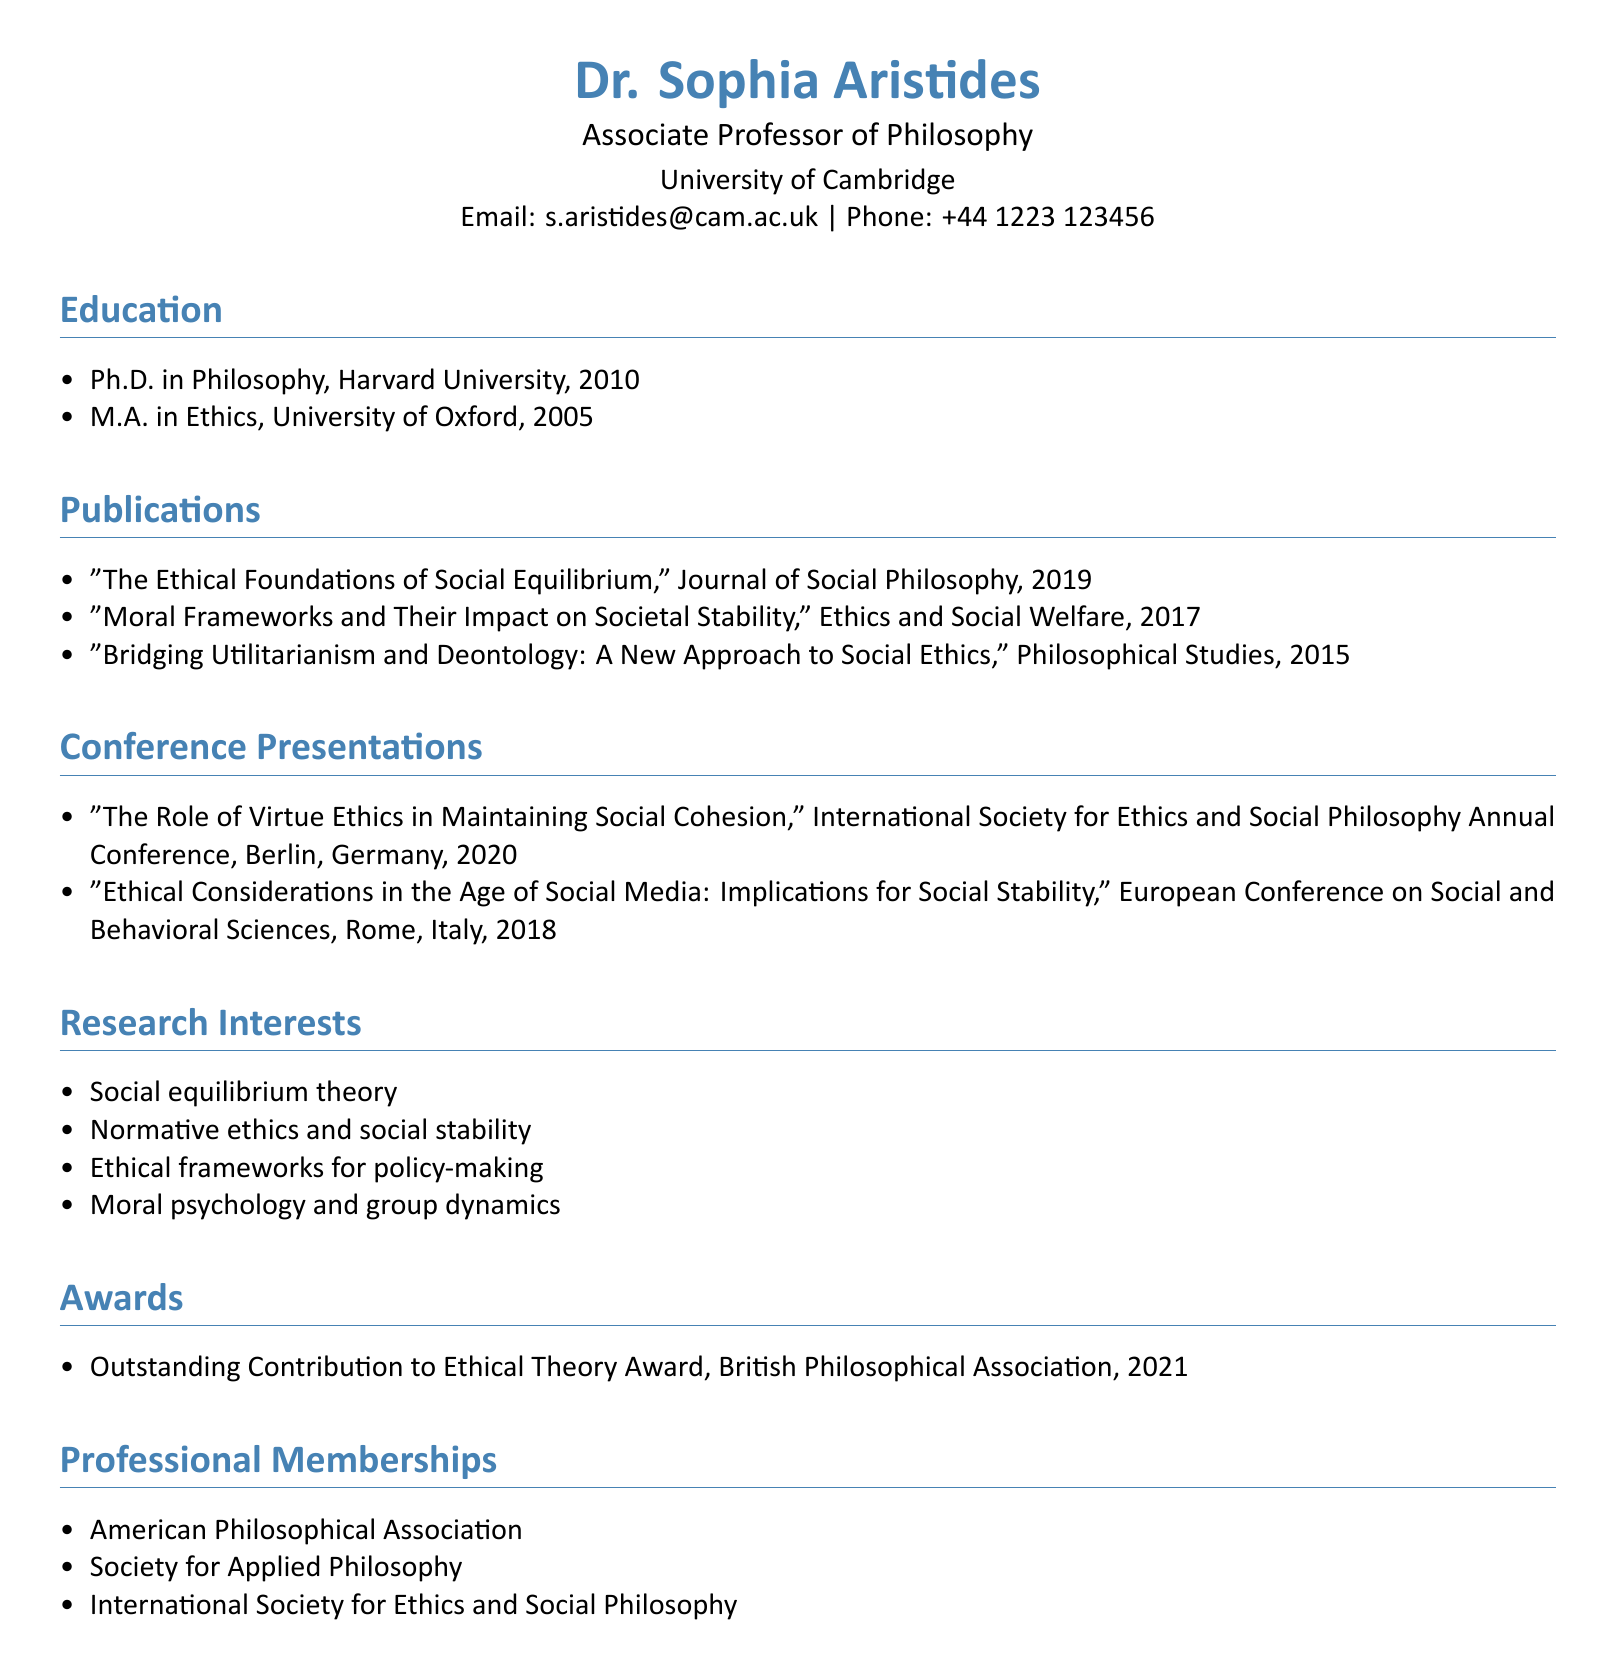What is Dr. Sophia Aristides's title? The title is a specific piece of information provided in the personal information section of the document.
Answer: Associate Professor of Philosophy In which year did Dr. Sophia Aristides complete her Ph.D.? This information is located under the education section where details about the Ph.D. are provided.
Answer: 2010 How many publications does Dr. Sophia Aristides have listed? The total number of publications is found by counting the items listed under the publications section.
Answer: 3 What was the title of the conference presentation in Berlin? This title can be found under the conference presentations section, specifically mentioning the Berlin conference.
Answer: The Role of Virtue Ethics in Maintaining Social Cohesion Which award did Dr. Sophia Aristides receive in 2021? The specific award is detailed under the awards section with its corresponding year.
Answer: Outstanding Contribution to Ethical Theory Award What are Dr. Sophia Aristides's research interests? This details her academic focus areas listed in a separate section of the document.
Answer: Social equilibrium theory, Normative ethics and social stability, Ethical frameworks for policy-making, Moral psychology and group dynamics Name one professional membership of Dr. Sophia Aristides. This information can be found in the professional memberships section, which lists various organizations.
Answer: American Philosophical Association In which country was the European Conference on Social and Behavioral Sciences held? The location of the conference is specified in the conference presentations section.
Answer: Italy What is the name of the journal where her 2019 publication appeared? The journal name is explicitly stated alongside the publication title in the publications section.
Answer: Journal of Social Philosophy 